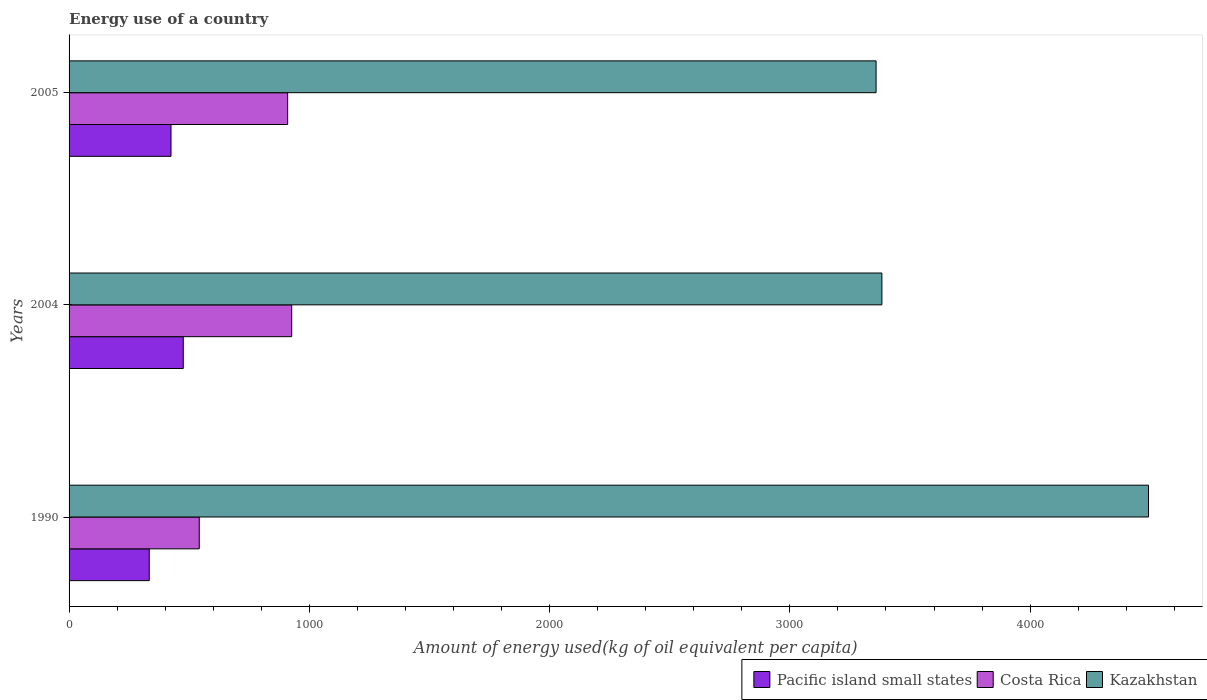How many groups of bars are there?
Offer a very short reply. 3. Are the number of bars per tick equal to the number of legend labels?
Keep it short and to the point. Yes. How many bars are there on the 3rd tick from the bottom?
Provide a succinct answer. 3. In how many cases, is the number of bars for a given year not equal to the number of legend labels?
Offer a terse response. 0. What is the amount of energy used in in Costa Rica in 1990?
Make the answer very short. 541.92. Across all years, what is the maximum amount of energy used in in Kazakhstan?
Keep it short and to the point. 4492.85. Across all years, what is the minimum amount of energy used in in Pacific island small states?
Offer a terse response. 333.8. In which year was the amount of energy used in in Pacific island small states minimum?
Your answer should be very brief. 1990. What is the total amount of energy used in in Kazakhstan in the graph?
Keep it short and to the point. 1.12e+04. What is the difference between the amount of energy used in in Costa Rica in 1990 and that in 2004?
Ensure brevity in your answer.  -384.72. What is the difference between the amount of energy used in in Pacific island small states in 2004 and the amount of energy used in in Costa Rica in 1990?
Offer a terse response. -66.62. What is the average amount of energy used in in Kazakhstan per year?
Your answer should be very brief. 3744.97. In the year 2005, what is the difference between the amount of energy used in in Pacific island small states and amount of energy used in in Kazakhstan?
Offer a very short reply. -2934.7. In how many years, is the amount of energy used in in Kazakhstan greater than 3600 kg?
Ensure brevity in your answer.  1. What is the ratio of the amount of energy used in in Kazakhstan in 1990 to that in 2004?
Provide a short and direct response. 1.33. Is the amount of energy used in in Kazakhstan in 1990 less than that in 2004?
Your answer should be compact. No. What is the difference between the highest and the second highest amount of energy used in in Pacific island small states?
Give a very brief answer. 51.03. What is the difference between the highest and the lowest amount of energy used in in Kazakhstan?
Your response must be concise. 1133.88. Is the sum of the amount of energy used in in Costa Rica in 1990 and 2005 greater than the maximum amount of energy used in in Pacific island small states across all years?
Provide a short and direct response. Yes. What does the 3rd bar from the top in 2004 represents?
Offer a very short reply. Pacific island small states. What does the 3rd bar from the bottom in 2005 represents?
Your answer should be very brief. Kazakhstan. Are all the bars in the graph horizontal?
Make the answer very short. Yes. What is the difference between two consecutive major ticks on the X-axis?
Your answer should be compact. 1000. Does the graph contain any zero values?
Provide a short and direct response. No. Does the graph contain grids?
Your answer should be very brief. No. How many legend labels are there?
Keep it short and to the point. 3. What is the title of the graph?
Offer a terse response. Energy use of a country. What is the label or title of the X-axis?
Your answer should be very brief. Amount of energy used(kg of oil equivalent per capita). What is the Amount of energy used(kg of oil equivalent per capita) of Pacific island small states in 1990?
Offer a very short reply. 333.8. What is the Amount of energy used(kg of oil equivalent per capita) in Costa Rica in 1990?
Keep it short and to the point. 541.92. What is the Amount of energy used(kg of oil equivalent per capita) in Kazakhstan in 1990?
Provide a short and direct response. 4492.85. What is the Amount of energy used(kg of oil equivalent per capita) in Pacific island small states in 2004?
Make the answer very short. 475.29. What is the Amount of energy used(kg of oil equivalent per capita) of Costa Rica in 2004?
Ensure brevity in your answer.  926.63. What is the Amount of energy used(kg of oil equivalent per capita) of Kazakhstan in 2004?
Make the answer very short. 3383.07. What is the Amount of energy used(kg of oil equivalent per capita) in Pacific island small states in 2005?
Your answer should be compact. 424.27. What is the Amount of energy used(kg of oil equivalent per capita) in Costa Rica in 2005?
Offer a terse response. 909.82. What is the Amount of energy used(kg of oil equivalent per capita) of Kazakhstan in 2005?
Give a very brief answer. 3358.97. Across all years, what is the maximum Amount of energy used(kg of oil equivalent per capita) in Pacific island small states?
Provide a short and direct response. 475.29. Across all years, what is the maximum Amount of energy used(kg of oil equivalent per capita) of Costa Rica?
Your answer should be compact. 926.63. Across all years, what is the maximum Amount of energy used(kg of oil equivalent per capita) in Kazakhstan?
Your answer should be very brief. 4492.85. Across all years, what is the minimum Amount of energy used(kg of oil equivalent per capita) in Pacific island small states?
Provide a succinct answer. 333.8. Across all years, what is the minimum Amount of energy used(kg of oil equivalent per capita) in Costa Rica?
Your answer should be very brief. 541.92. Across all years, what is the minimum Amount of energy used(kg of oil equivalent per capita) in Kazakhstan?
Ensure brevity in your answer.  3358.97. What is the total Amount of energy used(kg of oil equivalent per capita) in Pacific island small states in the graph?
Provide a short and direct response. 1233.36. What is the total Amount of energy used(kg of oil equivalent per capita) of Costa Rica in the graph?
Your answer should be very brief. 2378.37. What is the total Amount of energy used(kg of oil equivalent per capita) in Kazakhstan in the graph?
Offer a very short reply. 1.12e+04. What is the difference between the Amount of energy used(kg of oil equivalent per capita) of Pacific island small states in 1990 and that in 2004?
Give a very brief answer. -141.49. What is the difference between the Amount of energy used(kg of oil equivalent per capita) in Costa Rica in 1990 and that in 2004?
Keep it short and to the point. -384.72. What is the difference between the Amount of energy used(kg of oil equivalent per capita) of Kazakhstan in 1990 and that in 2004?
Provide a short and direct response. 1109.78. What is the difference between the Amount of energy used(kg of oil equivalent per capita) of Pacific island small states in 1990 and that in 2005?
Offer a terse response. -90.47. What is the difference between the Amount of energy used(kg of oil equivalent per capita) in Costa Rica in 1990 and that in 2005?
Your answer should be very brief. -367.9. What is the difference between the Amount of energy used(kg of oil equivalent per capita) in Kazakhstan in 1990 and that in 2005?
Make the answer very short. 1133.88. What is the difference between the Amount of energy used(kg of oil equivalent per capita) of Pacific island small states in 2004 and that in 2005?
Provide a succinct answer. 51.03. What is the difference between the Amount of energy used(kg of oil equivalent per capita) of Costa Rica in 2004 and that in 2005?
Your answer should be compact. 16.81. What is the difference between the Amount of energy used(kg of oil equivalent per capita) of Kazakhstan in 2004 and that in 2005?
Offer a terse response. 24.1. What is the difference between the Amount of energy used(kg of oil equivalent per capita) of Pacific island small states in 1990 and the Amount of energy used(kg of oil equivalent per capita) of Costa Rica in 2004?
Give a very brief answer. -592.83. What is the difference between the Amount of energy used(kg of oil equivalent per capita) of Pacific island small states in 1990 and the Amount of energy used(kg of oil equivalent per capita) of Kazakhstan in 2004?
Make the answer very short. -3049.27. What is the difference between the Amount of energy used(kg of oil equivalent per capita) in Costa Rica in 1990 and the Amount of energy used(kg of oil equivalent per capita) in Kazakhstan in 2004?
Your answer should be compact. -2841.16. What is the difference between the Amount of energy used(kg of oil equivalent per capita) in Pacific island small states in 1990 and the Amount of energy used(kg of oil equivalent per capita) in Costa Rica in 2005?
Give a very brief answer. -576.02. What is the difference between the Amount of energy used(kg of oil equivalent per capita) in Pacific island small states in 1990 and the Amount of energy used(kg of oil equivalent per capita) in Kazakhstan in 2005?
Make the answer very short. -3025.17. What is the difference between the Amount of energy used(kg of oil equivalent per capita) in Costa Rica in 1990 and the Amount of energy used(kg of oil equivalent per capita) in Kazakhstan in 2005?
Make the answer very short. -2817.06. What is the difference between the Amount of energy used(kg of oil equivalent per capita) in Pacific island small states in 2004 and the Amount of energy used(kg of oil equivalent per capita) in Costa Rica in 2005?
Keep it short and to the point. -434.53. What is the difference between the Amount of energy used(kg of oil equivalent per capita) of Pacific island small states in 2004 and the Amount of energy used(kg of oil equivalent per capita) of Kazakhstan in 2005?
Provide a succinct answer. -2883.68. What is the difference between the Amount of energy used(kg of oil equivalent per capita) in Costa Rica in 2004 and the Amount of energy used(kg of oil equivalent per capita) in Kazakhstan in 2005?
Your response must be concise. -2432.34. What is the average Amount of energy used(kg of oil equivalent per capita) of Pacific island small states per year?
Make the answer very short. 411.12. What is the average Amount of energy used(kg of oil equivalent per capita) of Costa Rica per year?
Provide a succinct answer. 792.79. What is the average Amount of energy used(kg of oil equivalent per capita) of Kazakhstan per year?
Keep it short and to the point. 3744.97. In the year 1990, what is the difference between the Amount of energy used(kg of oil equivalent per capita) in Pacific island small states and Amount of energy used(kg of oil equivalent per capita) in Costa Rica?
Provide a short and direct response. -208.12. In the year 1990, what is the difference between the Amount of energy used(kg of oil equivalent per capita) of Pacific island small states and Amount of energy used(kg of oil equivalent per capita) of Kazakhstan?
Keep it short and to the point. -4159.05. In the year 1990, what is the difference between the Amount of energy used(kg of oil equivalent per capita) of Costa Rica and Amount of energy used(kg of oil equivalent per capita) of Kazakhstan?
Offer a very short reply. -3950.94. In the year 2004, what is the difference between the Amount of energy used(kg of oil equivalent per capita) of Pacific island small states and Amount of energy used(kg of oil equivalent per capita) of Costa Rica?
Provide a short and direct response. -451.34. In the year 2004, what is the difference between the Amount of energy used(kg of oil equivalent per capita) in Pacific island small states and Amount of energy used(kg of oil equivalent per capita) in Kazakhstan?
Your response must be concise. -2907.78. In the year 2004, what is the difference between the Amount of energy used(kg of oil equivalent per capita) of Costa Rica and Amount of energy used(kg of oil equivalent per capita) of Kazakhstan?
Your answer should be compact. -2456.44. In the year 2005, what is the difference between the Amount of energy used(kg of oil equivalent per capita) in Pacific island small states and Amount of energy used(kg of oil equivalent per capita) in Costa Rica?
Your answer should be compact. -485.55. In the year 2005, what is the difference between the Amount of energy used(kg of oil equivalent per capita) of Pacific island small states and Amount of energy used(kg of oil equivalent per capita) of Kazakhstan?
Make the answer very short. -2934.7. In the year 2005, what is the difference between the Amount of energy used(kg of oil equivalent per capita) in Costa Rica and Amount of energy used(kg of oil equivalent per capita) in Kazakhstan?
Offer a very short reply. -2449.15. What is the ratio of the Amount of energy used(kg of oil equivalent per capita) of Pacific island small states in 1990 to that in 2004?
Ensure brevity in your answer.  0.7. What is the ratio of the Amount of energy used(kg of oil equivalent per capita) in Costa Rica in 1990 to that in 2004?
Offer a very short reply. 0.58. What is the ratio of the Amount of energy used(kg of oil equivalent per capita) in Kazakhstan in 1990 to that in 2004?
Keep it short and to the point. 1.33. What is the ratio of the Amount of energy used(kg of oil equivalent per capita) in Pacific island small states in 1990 to that in 2005?
Provide a succinct answer. 0.79. What is the ratio of the Amount of energy used(kg of oil equivalent per capita) in Costa Rica in 1990 to that in 2005?
Make the answer very short. 0.6. What is the ratio of the Amount of energy used(kg of oil equivalent per capita) of Kazakhstan in 1990 to that in 2005?
Give a very brief answer. 1.34. What is the ratio of the Amount of energy used(kg of oil equivalent per capita) in Pacific island small states in 2004 to that in 2005?
Provide a succinct answer. 1.12. What is the ratio of the Amount of energy used(kg of oil equivalent per capita) in Costa Rica in 2004 to that in 2005?
Offer a terse response. 1.02. What is the difference between the highest and the second highest Amount of energy used(kg of oil equivalent per capita) in Pacific island small states?
Your answer should be compact. 51.03. What is the difference between the highest and the second highest Amount of energy used(kg of oil equivalent per capita) of Costa Rica?
Provide a succinct answer. 16.81. What is the difference between the highest and the second highest Amount of energy used(kg of oil equivalent per capita) in Kazakhstan?
Provide a short and direct response. 1109.78. What is the difference between the highest and the lowest Amount of energy used(kg of oil equivalent per capita) of Pacific island small states?
Provide a short and direct response. 141.49. What is the difference between the highest and the lowest Amount of energy used(kg of oil equivalent per capita) in Costa Rica?
Your response must be concise. 384.72. What is the difference between the highest and the lowest Amount of energy used(kg of oil equivalent per capita) in Kazakhstan?
Make the answer very short. 1133.88. 